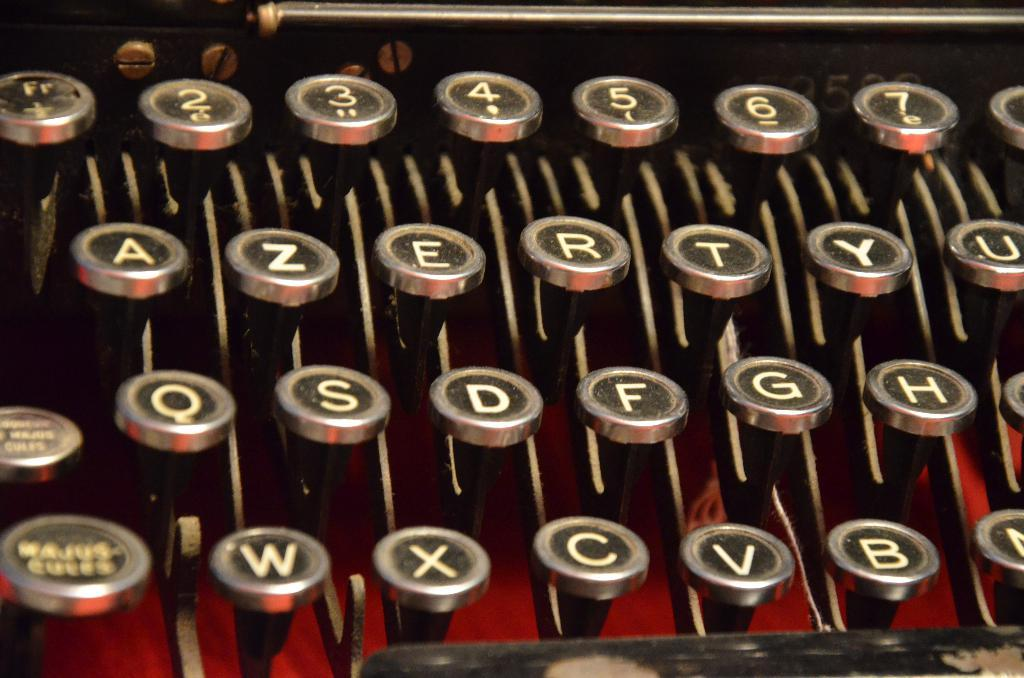<image>
Give a short and clear explanation of the subsequent image. The word majus is on the key next to the W on an typewriter. 